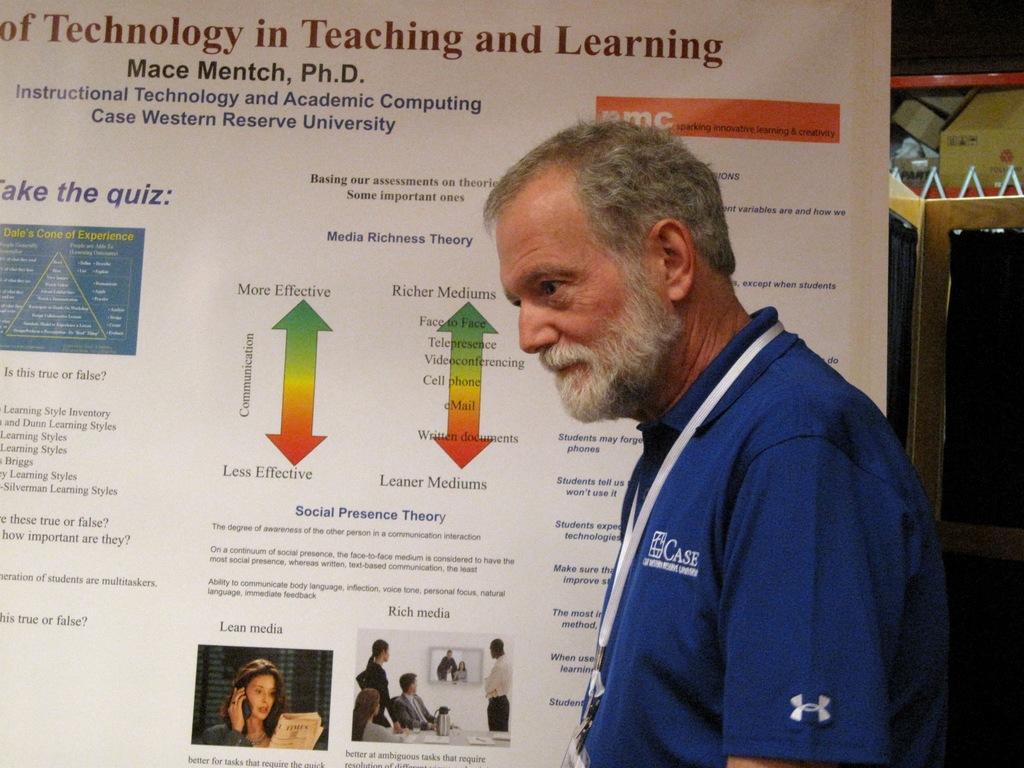Who is the doctor that wrote this?
Ensure brevity in your answer.  Mace mentch. What type of degree does mace montech have?
Your answer should be compact. Ph.d. 